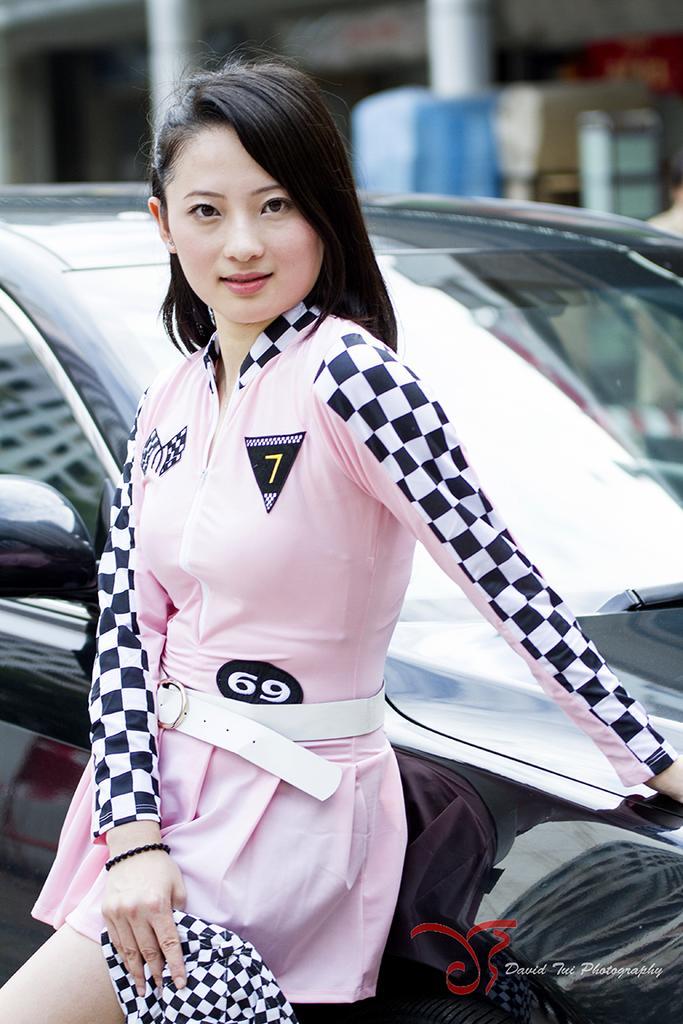Please provide a concise description of this image. Here we can see a woman standing by leaning on a car. In the background the image is not clear but we can see pillars and some other objects, 